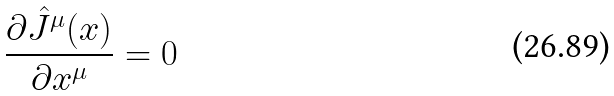Convert formula to latex. <formula><loc_0><loc_0><loc_500><loc_500>\frac { \partial { \hat { J } } ^ { \mu } ( x ) } { \partial x ^ { \mu } } = 0</formula> 